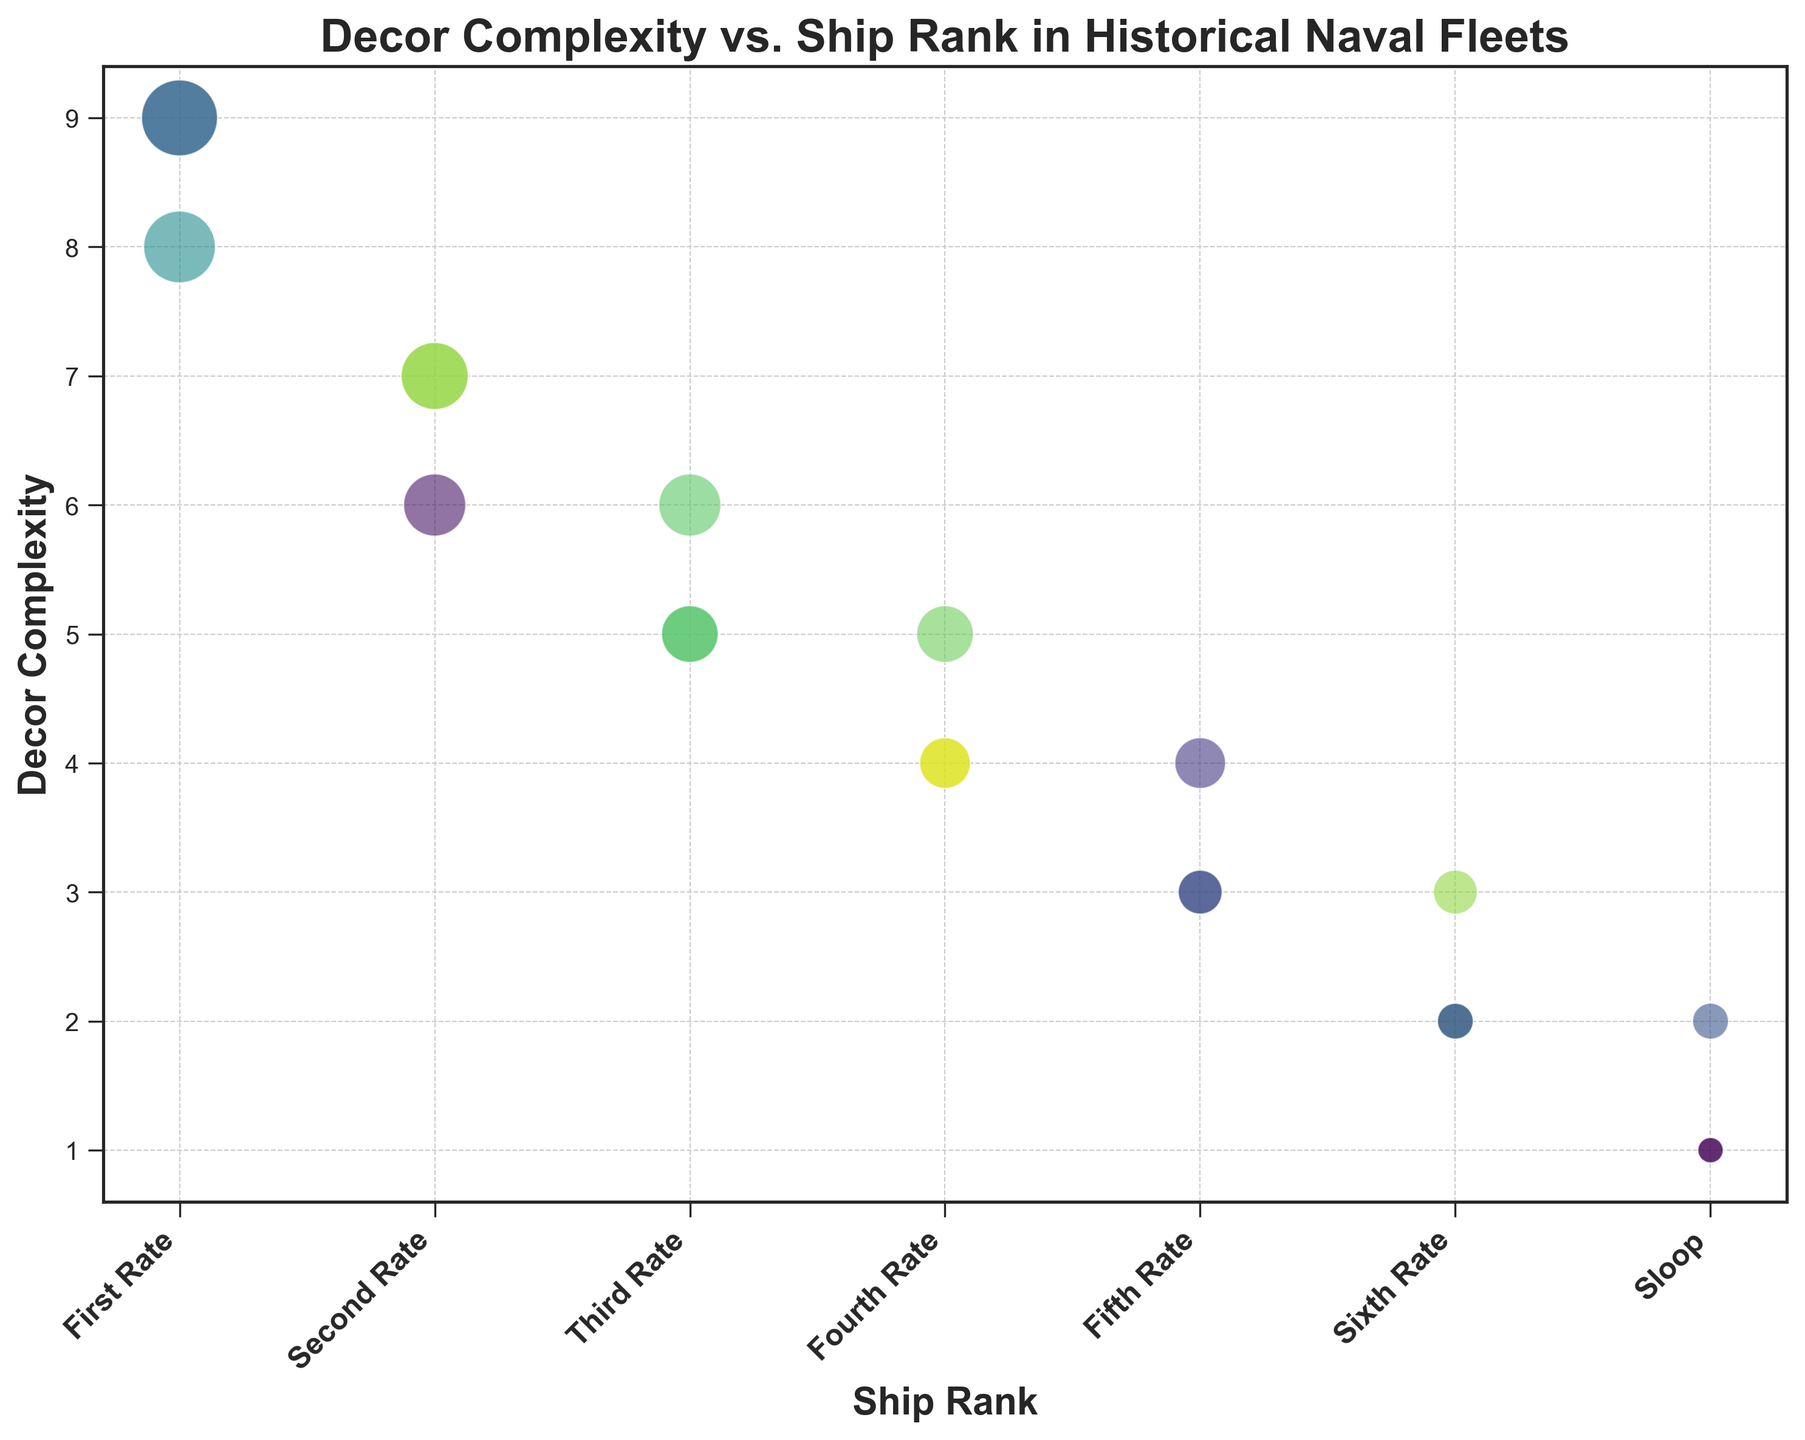What is the range of decor complexity for a "First Rate" ship? To find the range, identify the maximum and minimum values of decor complexity for "First Rate" ships. These values are 9 and 8. The range is 9 - 8 = 1
Answer: 1 Which ship rank has the highest average decor complexity? To determine the average decor complexity for each ship rank, calculate the sum of decor complexities for each rank and then divide by the number of ships in that rank. "First Rate" has an average decor complexity of (9+8+9)/3 = 8.67, which is the highest among all ranks.
Answer: First Rate How many ship ranks have a decor complexity of 5? Identify the ship ranks where any ships have a decor complexity of 5. This occurs in "Third Rate" and "Fourth Rate". Thus, there are 2 ship ranks.
Answer: 2 Which ship rank has the most visually larger points (based on size) due to higher complexity? Visually larger scatter points indicate higher decor complexity. "First Rate" ships mostly have larger points since they have decor complexities of 8 and 9.
Answer: First Rate How does the decor complexity for "Second Rate" and "Third Rate" ships compare? Compare the values of decor complexities for "Second Rate" (7, 6, 7) and "Third Rate" (5, 5, 6). The highest value for "Second Rate" (7) is greater than that for "Third Rate" (6).
Answer: Second Rate has higher decor complexity What is the total decor complexity for all "Sloop" ships combined? Add up all decor complexities for "Sloop" ships: 1 + 1 + 2 = 4
Answer: 4 Do "Sixth Rate" ships consistently have a lower decor complexity than "Fourth Rate" ships? Compare the decor complexities of "Sixth Rate" (2, 2, 3) with "Fourth Rate" (4, 4, 5). All values of "Sixth Rate" are lower than those of "Fourth Rate".
Answer: Yes What is the difference in maximum decor complexity between "First Rate" and "Sloop" ships? The maximum decor complexity for "First Rate" is 9, while for "Sloop" it is 2. The difference is 9 - 2 = 7
Answer: 7 Which ship rank appears to have the most variability in decor complexity? Variability can be seen by looking at the range of values. "Fourth Rate" has values 4, 4, 5; "Fifth Rate" has values 3, 3, 4, etc. "First Rate" has values 8, 9, 9. "First Rate" shows the largest difference between minimum and maximum complexity.
Answer: First Rate What is the median decor complexity for "Third Rate" ships? Arrange the decor complexities for "Third Rate" ships (5, 5, 6) in ascending order. The middle value is 5.
Answer: 5 